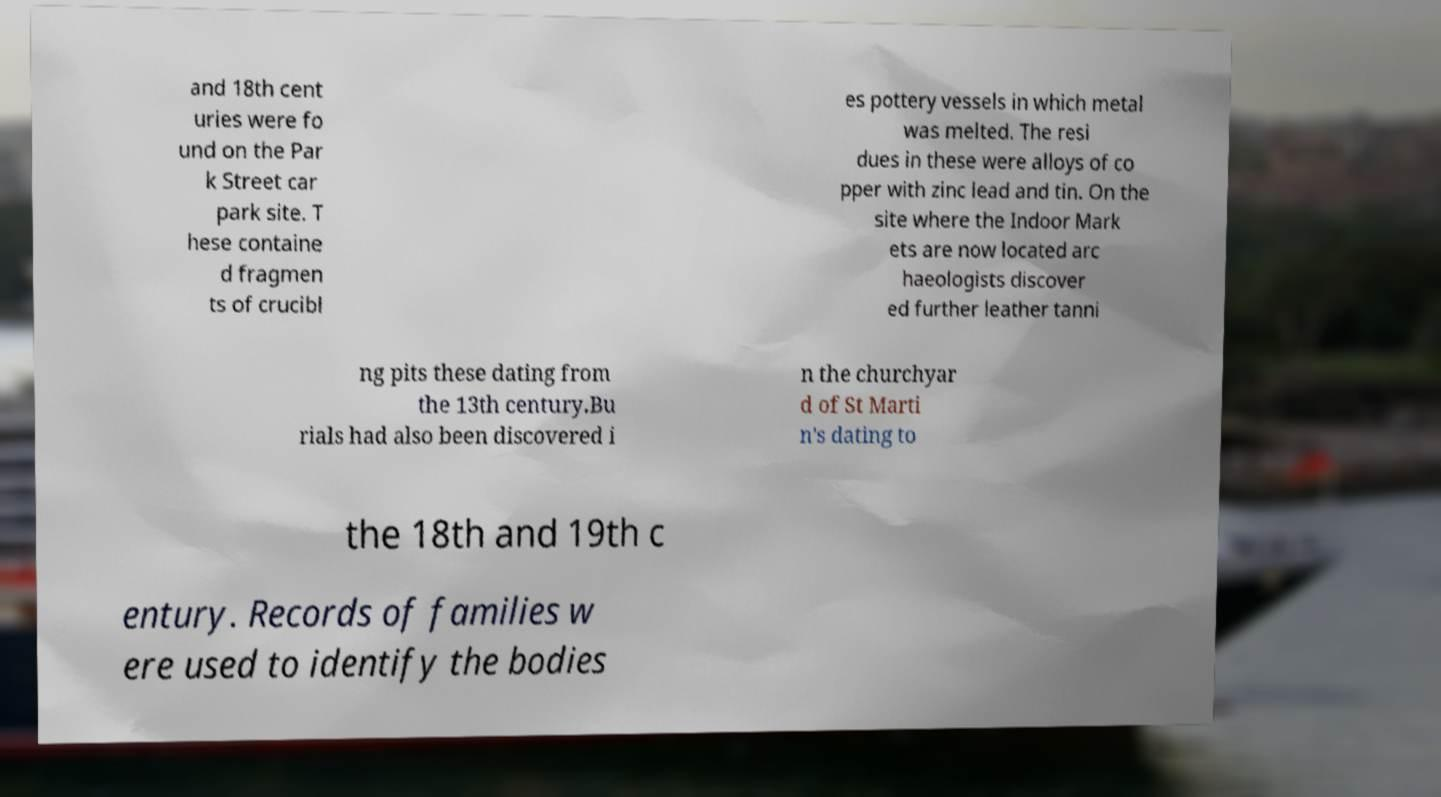Could you extract and type out the text from this image? and 18th cent uries were fo und on the Par k Street car park site. T hese containe d fragmen ts of crucibl es pottery vessels in which metal was melted. The resi dues in these were alloys of co pper with zinc lead and tin. On the site where the Indoor Mark ets are now located arc haeologists discover ed further leather tanni ng pits these dating from the 13th century.Bu rials had also been discovered i n the churchyar d of St Marti n's dating to the 18th and 19th c entury. Records of families w ere used to identify the bodies 